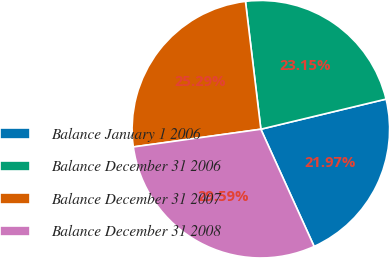Convert chart. <chart><loc_0><loc_0><loc_500><loc_500><pie_chart><fcel>Balance January 1 2006<fcel>Balance December 31 2006<fcel>Balance December 31 2007<fcel>Balance December 31 2008<nl><fcel>21.97%<fcel>23.15%<fcel>25.29%<fcel>29.59%<nl></chart> 